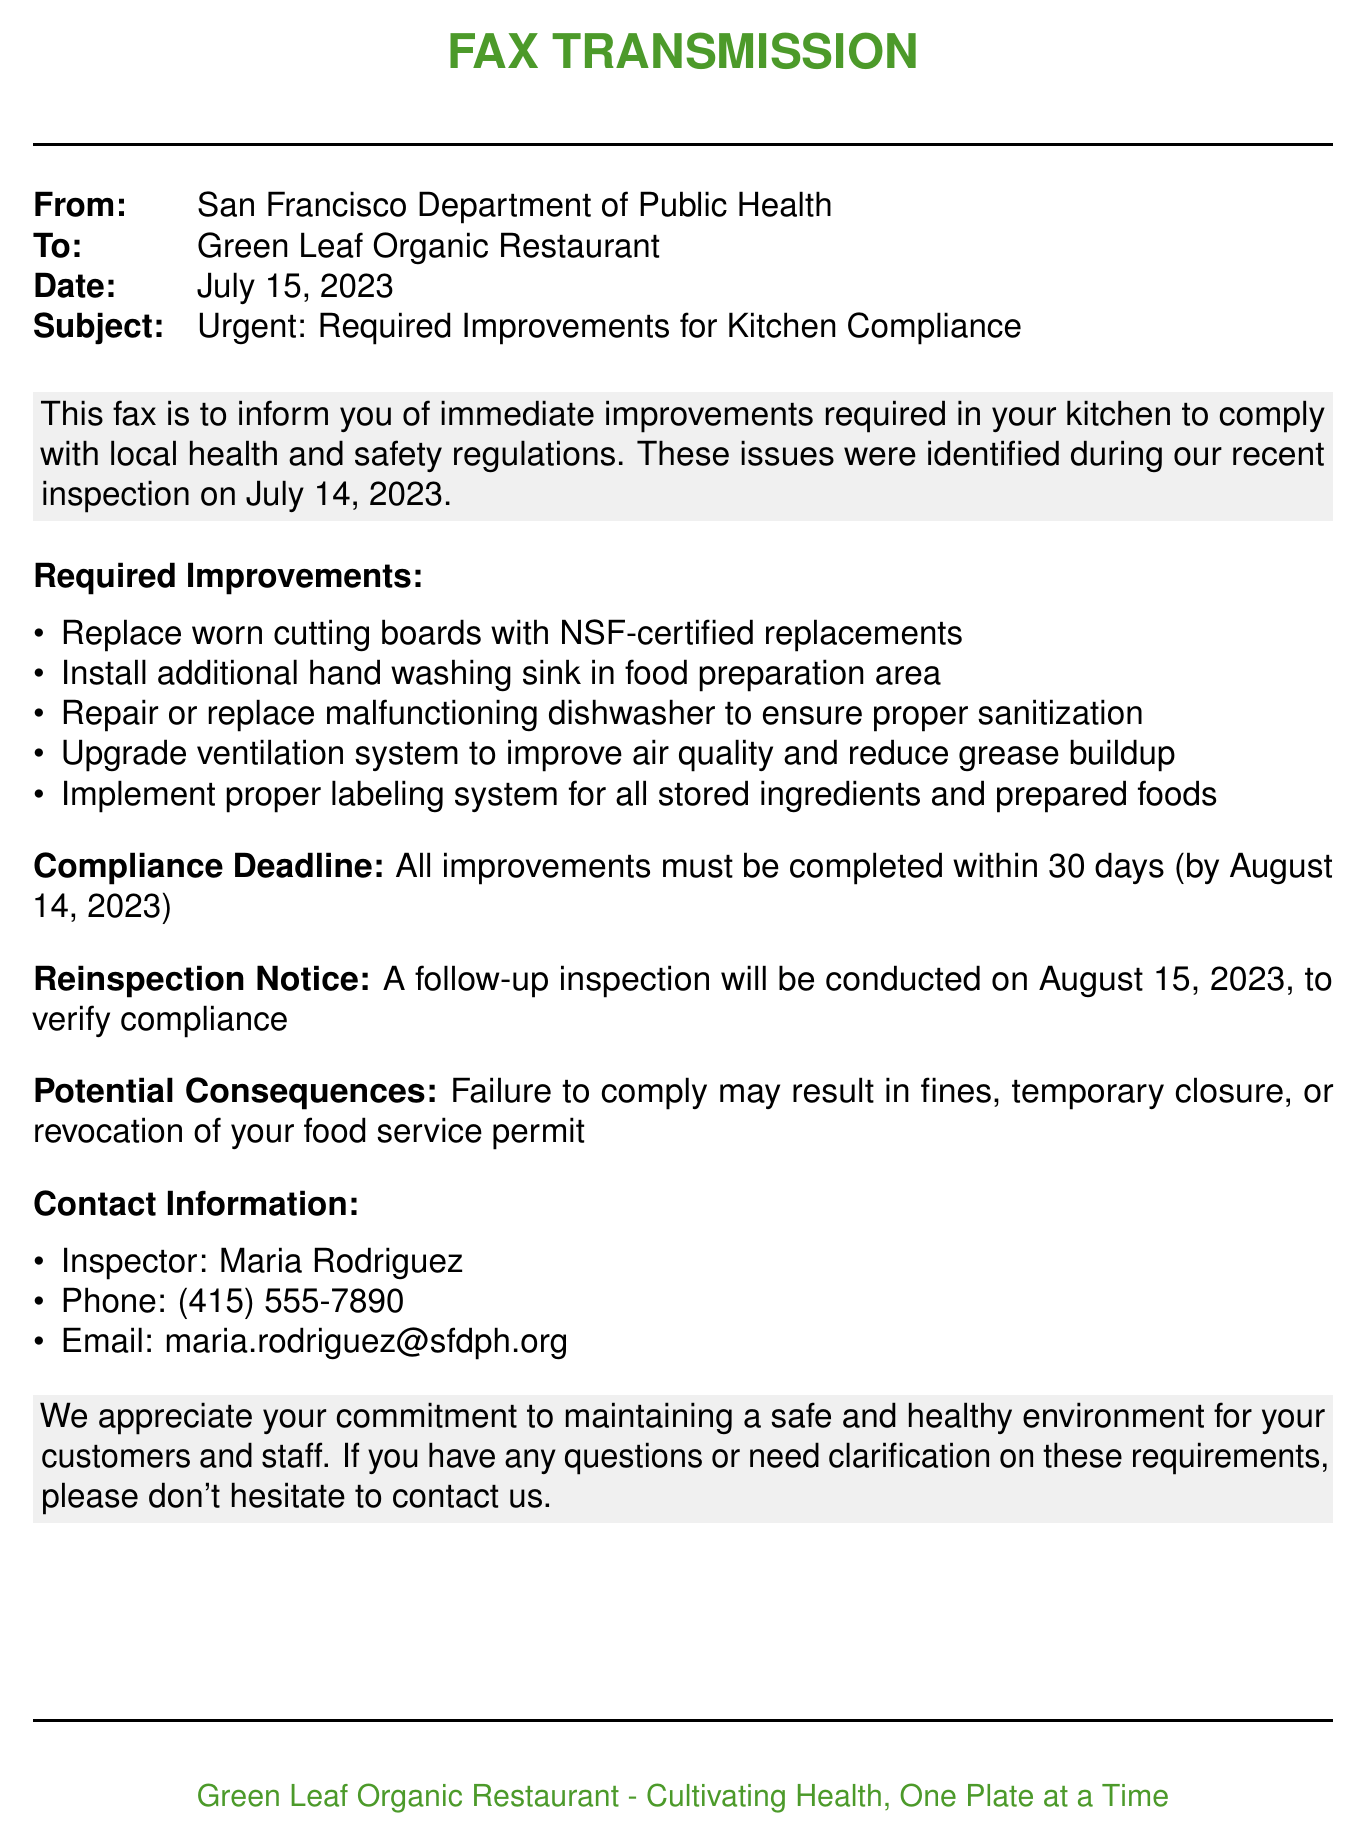What is the date of inspection? The inspection date is mentioned in the document, which is July 14, 2023.
Answer: July 14, 2023 Who is the health inspector? The document specifies the health inspector's name directly.
Answer: Maria Rodriguez What is the compliance deadline? The deadline for compliance is clearly stated in the fax.
Answer: August 14, 2023 What is one of the required improvements? The document lists multiple required improvements, one of which can be cited here.
Answer: Replace worn cutting boards with NSF-certified replacements What could happen if the restaurant fails to comply? The fax outlines potential consequences for non-compliance.
Answer: fines, temporary closure, or revocation of your food service permit What is the phone number of the inspector? The document provides direct contact information for the inspector, including a phone number.
Answer: (415) 555-7890 When will the reinspection occur? The document clearly states when the follow-up inspection will take place.
Answer: August 15, 2023 How many improvements need to be made? The document lists specific improvements, totaling a certain number.
Answer: five improvements 